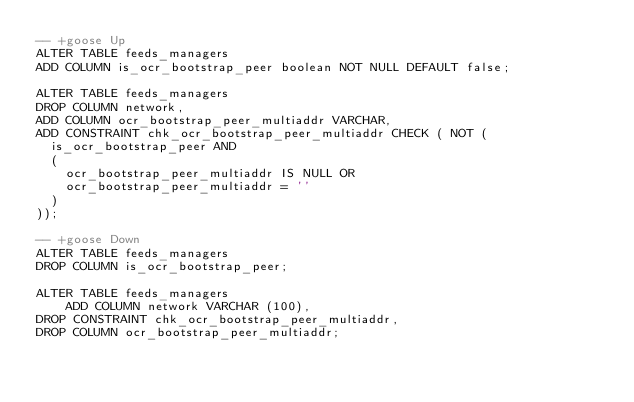<code> <loc_0><loc_0><loc_500><loc_500><_SQL_>-- +goose Up
ALTER TABLE feeds_managers
ADD COLUMN is_ocr_bootstrap_peer boolean NOT NULL DEFAULT false;

ALTER TABLE feeds_managers
DROP COLUMN network,
ADD COLUMN ocr_bootstrap_peer_multiaddr VARCHAR,
ADD CONSTRAINT chk_ocr_bootstrap_peer_multiaddr CHECK ( NOT (
	is_ocr_bootstrap_peer AND
	(
		ocr_bootstrap_peer_multiaddr IS NULL OR
		ocr_bootstrap_peer_multiaddr = ''
	)
));

-- +goose Down
ALTER TABLE feeds_managers
DROP COLUMN is_ocr_bootstrap_peer;

ALTER TABLE feeds_managers
    ADD COLUMN network VARCHAR (100),
DROP CONSTRAINT chk_ocr_bootstrap_peer_multiaddr,
DROP COLUMN ocr_bootstrap_peer_multiaddr;
</code> 